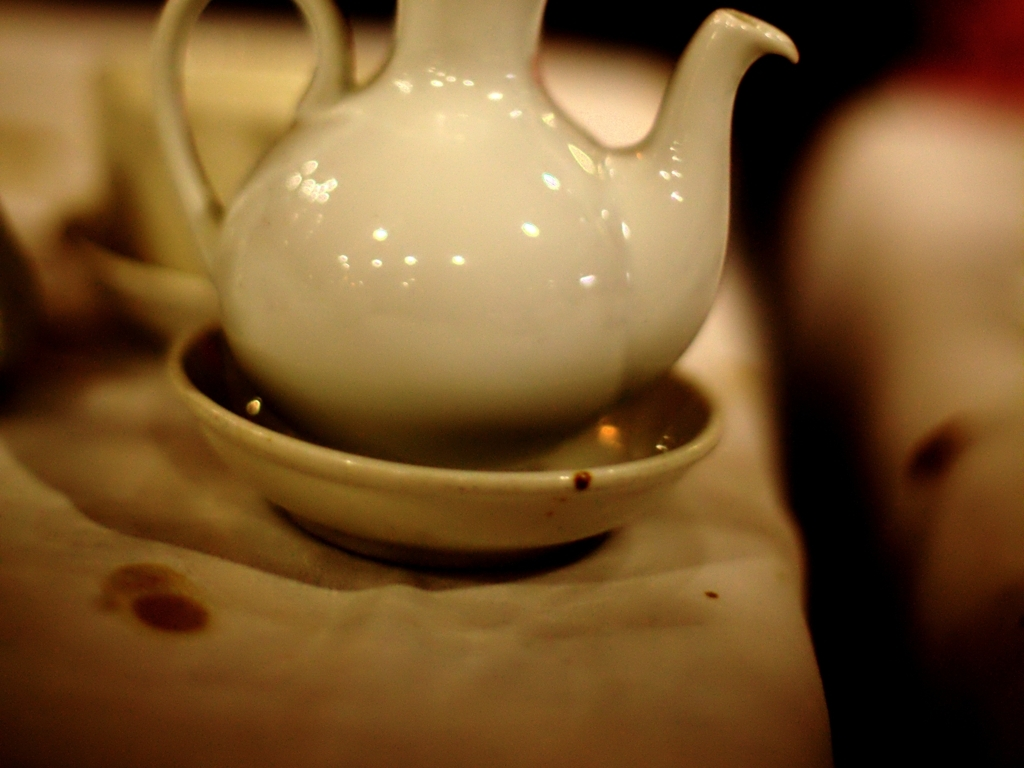Could this be a part of a larger set or collection? Yes, the teapot's design and the matching saucer suggest it could belong to a larger set of similar style ceramicware, often used for serving tea or coffee in a cohesive presentation. 